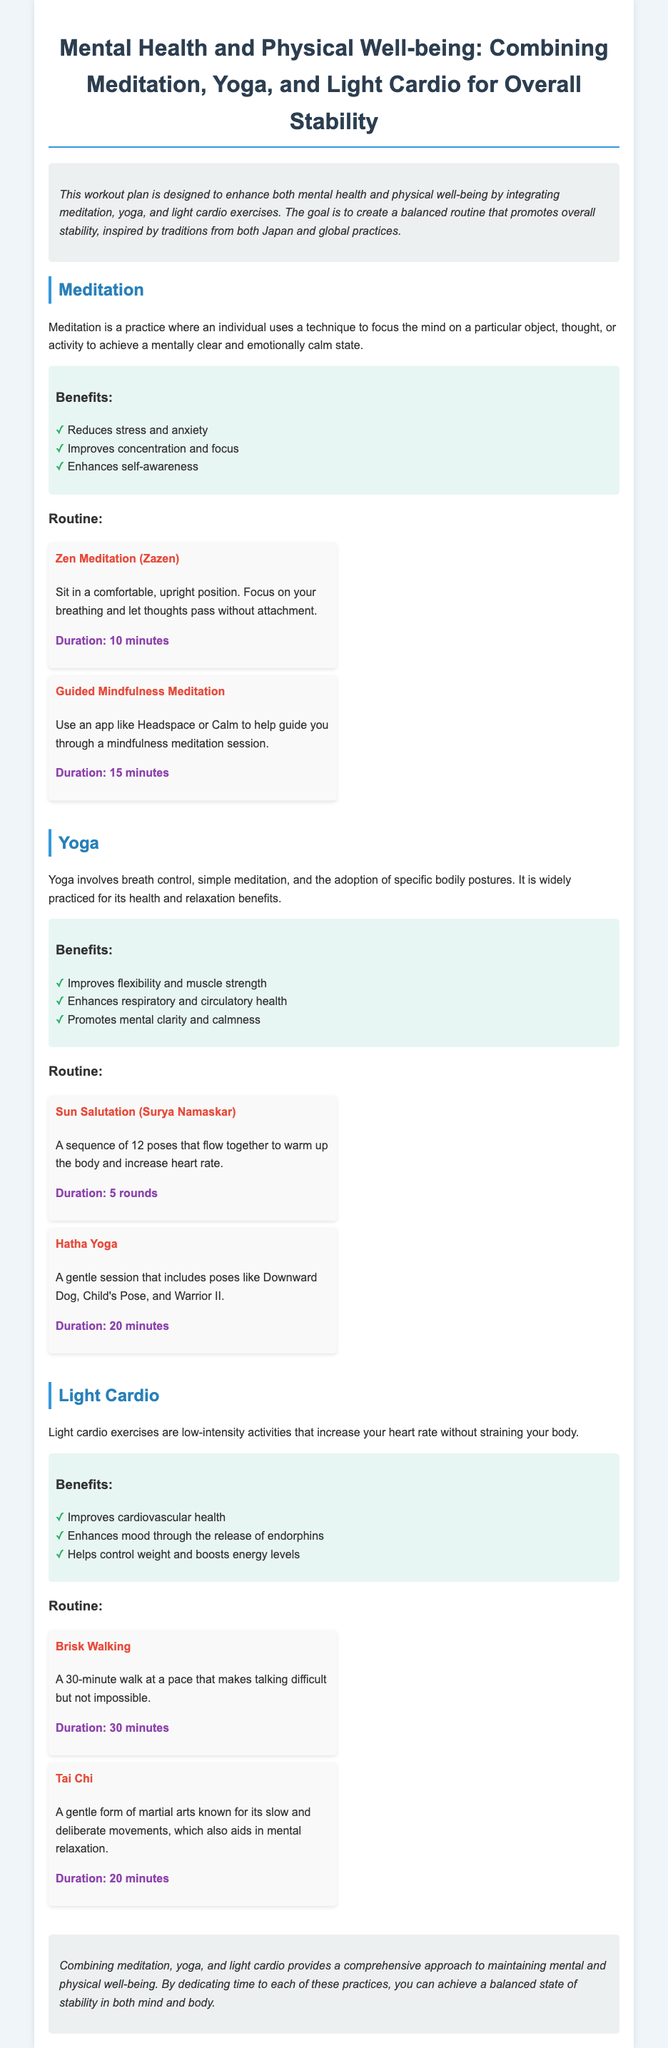What is the main purpose of the workout plan? The main purpose of the workout plan is to enhance both mental health and physical well-being by integrating meditation, yoga, and light cardio exercises.
Answer: Enhance mental health and physical well-being What is the duration of Zen Meditation? The duration of Zen Meditation is specified in the document as a practice.
Answer: 10 minutes List one benefit of practicing meditation. One of the benefits of meditation includes improving concentration and focus.
Answer: Improves concentration and focus How many rounds of Sun Salutation are recommended? The document outlines the recommended number of rounds for Sun Salutation.
Answer: 5 rounds What type of yoga is mentioned in the routine? The document contains a specific type of yoga included in the routine.
Answer: Hatha Yoga What is the duration for brisk walking? The document specifies how long an individual should engage in brisk walking.
Answer: 30 minutes What is a benefit of light cardio exercises? The document lists several benefits of light cardio exercises; one of them is mentioned here.
Answer: Improves cardiovascular health What style of meditation uses an app for guidance? The document describes a meditation style that utilizes technology for assistance.
Answer: Guided Mindfulness Meditation Identify one yoga pose mentioned in the routine. The routine includes specific poses, and one is asked for in this question.
Answer: Warrior II 